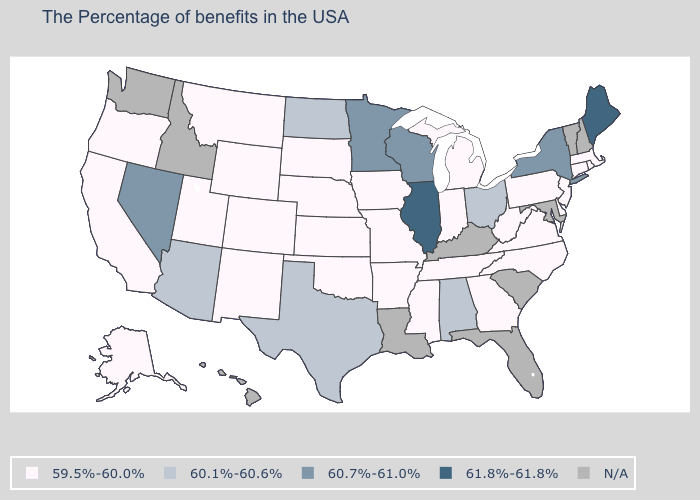What is the lowest value in the Northeast?
Give a very brief answer. 59.5%-60.0%. Name the states that have a value in the range 59.5%-60.0%?
Concise answer only. Massachusetts, Rhode Island, Connecticut, New Jersey, Delaware, Pennsylvania, Virginia, North Carolina, West Virginia, Georgia, Michigan, Indiana, Tennessee, Mississippi, Missouri, Arkansas, Iowa, Kansas, Nebraska, Oklahoma, South Dakota, Wyoming, Colorado, New Mexico, Utah, Montana, California, Oregon, Alaska. Name the states that have a value in the range 60.1%-60.6%?
Quick response, please. Ohio, Alabama, Texas, North Dakota, Arizona. Is the legend a continuous bar?
Keep it brief. No. Name the states that have a value in the range 60.7%-61.0%?
Keep it brief. New York, Wisconsin, Minnesota, Nevada. What is the value of Maryland?
Answer briefly. N/A. What is the highest value in states that border Ohio?
Keep it brief. 59.5%-60.0%. What is the highest value in the USA?
Be succinct. 61.8%-61.8%. Does the first symbol in the legend represent the smallest category?
Be succinct. Yes. Does Tennessee have the lowest value in the South?
Keep it brief. Yes. Name the states that have a value in the range 61.8%-61.8%?
Be succinct. Maine, Illinois. What is the value of Arkansas?
Give a very brief answer. 59.5%-60.0%. Which states have the lowest value in the USA?
Write a very short answer. Massachusetts, Rhode Island, Connecticut, New Jersey, Delaware, Pennsylvania, Virginia, North Carolina, West Virginia, Georgia, Michigan, Indiana, Tennessee, Mississippi, Missouri, Arkansas, Iowa, Kansas, Nebraska, Oklahoma, South Dakota, Wyoming, Colorado, New Mexico, Utah, Montana, California, Oregon, Alaska. How many symbols are there in the legend?
Answer briefly. 5. 